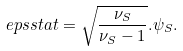Convert formula to latex. <formula><loc_0><loc_0><loc_500><loc_500>\ e p s { s t a t } = \sqrt { \frac { \nu _ { S } } { \nu _ { S } - 1 } } . \psi _ { S } .</formula> 